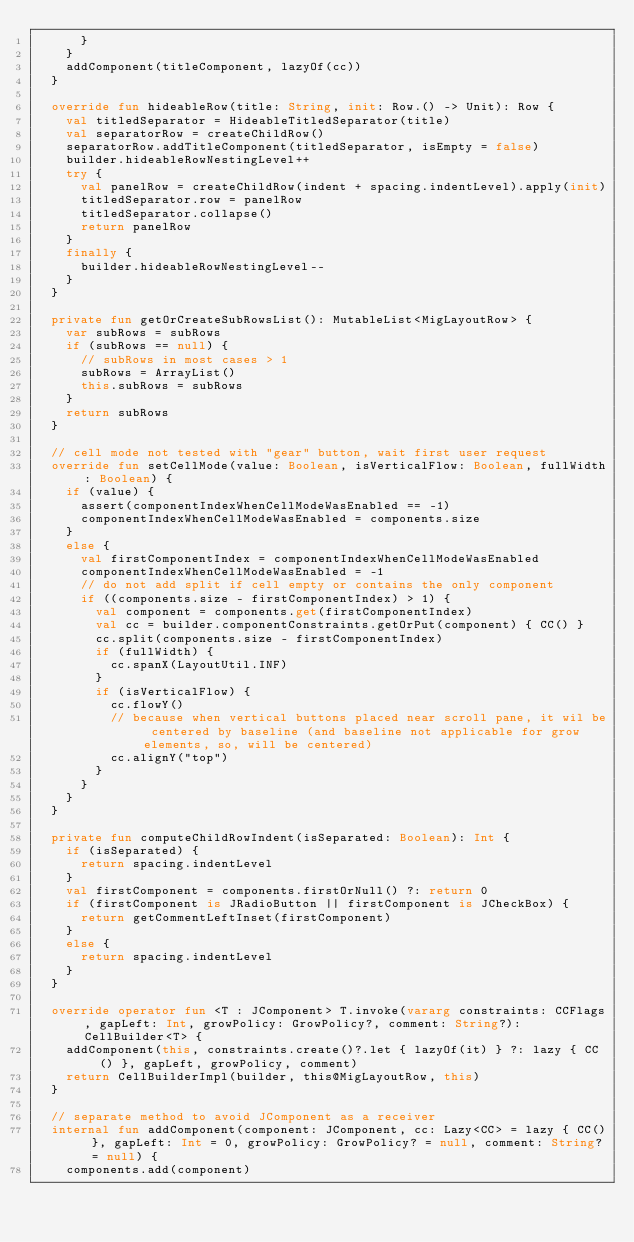<code> <loc_0><loc_0><loc_500><loc_500><_Kotlin_>      }
    }
    addComponent(titleComponent, lazyOf(cc))
  }

  override fun hideableRow(title: String, init: Row.() -> Unit): Row {
    val titledSeparator = HideableTitledSeparator(title)
    val separatorRow = createChildRow()
    separatorRow.addTitleComponent(titledSeparator, isEmpty = false)
    builder.hideableRowNestingLevel++
    try {
      val panelRow = createChildRow(indent + spacing.indentLevel).apply(init)
      titledSeparator.row = panelRow
      titledSeparator.collapse()
      return panelRow
    }
    finally {
      builder.hideableRowNestingLevel--
    }
  }

  private fun getOrCreateSubRowsList(): MutableList<MigLayoutRow> {
    var subRows = subRows
    if (subRows == null) {
      // subRows in most cases > 1
      subRows = ArrayList()
      this.subRows = subRows
    }
    return subRows
  }

  // cell mode not tested with "gear" button, wait first user request
  override fun setCellMode(value: Boolean, isVerticalFlow: Boolean, fullWidth: Boolean) {
    if (value) {
      assert(componentIndexWhenCellModeWasEnabled == -1)
      componentIndexWhenCellModeWasEnabled = components.size
    }
    else {
      val firstComponentIndex = componentIndexWhenCellModeWasEnabled
      componentIndexWhenCellModeWasEnabled = -1
      // do not add split if cell empty or contains the only component
      if ((components.size - firstComponentIndex) > 1) {
        val component = components.get(firstComponentIndex)
        val cc = builder.componentConstraints.getOrPut(component) { CC() }
        cc.split(components.size - firstComponentIndex)
        if (fullWidth) {
          cc.spanX(LayoutUtil.INF)
        }
        if (isVerticalFlow) {
          cc.flowY()
          // because when vertical buttons placed near scroll pane, it wil be centered by baseline (and baseline not applicable for grow elements, so, will be centered)
          cc.alignY("top")
        }
      }
    }
  }

  private fun computeChildRowIndent(isSeparated: Boolean): Int {
    if (isSeparated) {
      return spacing.indentLevel
    }
    val firstComponent = components.firstOrNull() ?: return 0
    if (firstComponent is JRadioButton || firstComponent is JCheckBox) {
      return getCommentLeftInset(firstComponent)
    }
    else {
      return spacing.indentLevel
    }
  }

  override operator fun <T : JComponent> T.invoke(vararg constraints: CCFlags, gapLeft: Int, growPolicy: GrowPolicy?, comment: String?): CellBuilder<T> {
    addComponent(this, constraints.create()?.let { lazyOf(it) } ?: lazy { CC() }, gapLeft, growPolicy, comment)
    return CellBuilderImpl(builder, this@MigLayoutRow, this)
  }

  // separate method to avoid JComponent as a receiver
  internal fun addComponent(component: JComponent, cc: Lazy<CC> = lazy { CC() }, gapLeft: Int = 0, growPolicy: GrowPolicy? = null, comment: String? = null) {
    components.add(component)
</code> 